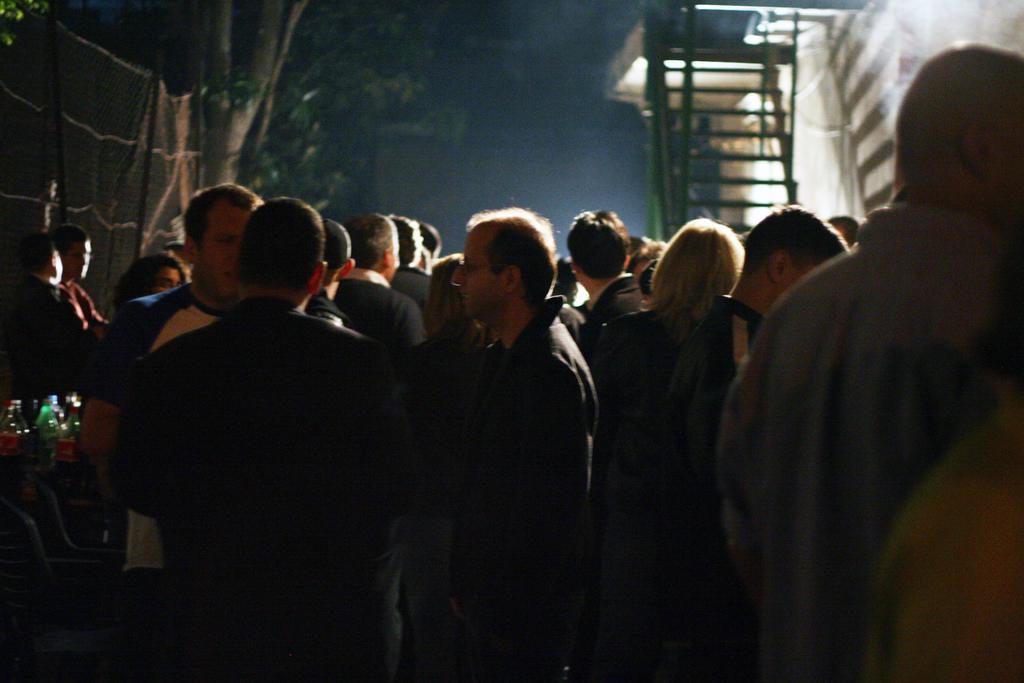Please provide a concise description of this image. In the picture we can see a group of people standing on the path and they are in black clothes and besides the we can see a fencing wall and a tree and on the other side, we can see a building wall with some steps and railing to it. and in the background we can see a sky which is dark. 